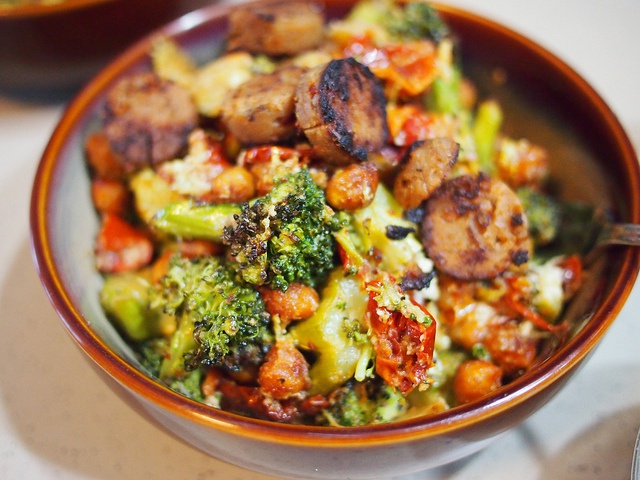Describe the objects in this image and their specific colors. I can see bowl in olive, maroon, brown, black, and tan tones, dining table in olive, lightgray, and tan tones, broccoli in olive and black tones, broccoli in olive and black tones, and spoon in olive, black, maroon, and gray tones in this image. 